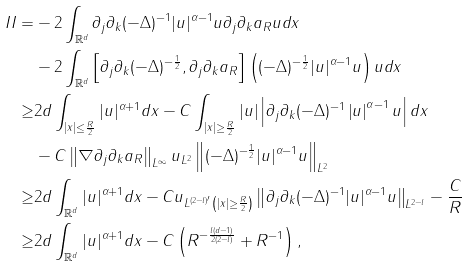<formula> <loc_0><loc_0><loc_500><loc_500>I I = & - 2 \int _ { \mathbb { R } ^ { d } } \partial _ { j } \partial _ { k } ( - \Delta ) ^ { - 1 } | u | ^ { \alpha - 1 } u \partial _ { j } \partial _ { k } a _ { R } u d x \\ & - 2 \int _ { \mathbb { R } ^ { d } } \left [ \partial _ { j } \partial _ { k } ( - \Delta ) ^ { - \frac { 1 } { 2 } } , \partial _ { j } \partial _ { k } a _ { R } \right ] \left ( ( - \Delta ) ^ { - \frac { 1 } { 2 } } | u | ^ { \alpha - 1 } u \right ) u d x \\ \geq & 2 d \int _ { | x | \leq \frac { R } { 2 } } | u | ^ { \alpha + 1 } d x - C \int _ { | x | \geq \frac { R } { 2 } } | u | \left | \partial _ { j } \partial _ { k } ( - \Delta ) ^ { - 1 } \left | u \right | ^ { \alpha - 1 } u \right | d x \\ & - C \left \| \nabla \partial _ { j } \partial _ { k } a _ { R } \right \| _ { L ^ { \infty } } \| u \| _ { L ^ { 2 } } \left \| ( - \Delta ) ^ { - \frac { 1 } { 2 } } | u | ^ { \alpha - 1 } u \right \| _ { L ^ { 2 } } \\ \geq & 2 d \int _ { \mathbb { R } ^ { d } } | u | ^ { \alpha + 1 } d x - C \| u \| _ { L ^ { ( 2 - l ) ^ { \prime } } \left ( | x | \geq \frac { R } { 2 } \right ) } \left \| \partial _ { j } \partial _ { k } ( - \Delta ) ^ { - 1 } | u | ^ { \alpha - 1 } u \right \| _ { L ^ { 2 - l } } - \frac { C } { R } \\ \geq & 2 d \int _ { \mathbb { R } ^ { d } } | u | ^ { \alpha + 1 } d x - C \left ( R ^ { - \frac { l ( d - 1 ) } { 2 ( 2 - l ) } } + R ^ { - 1 } \right ) ,</formula> 